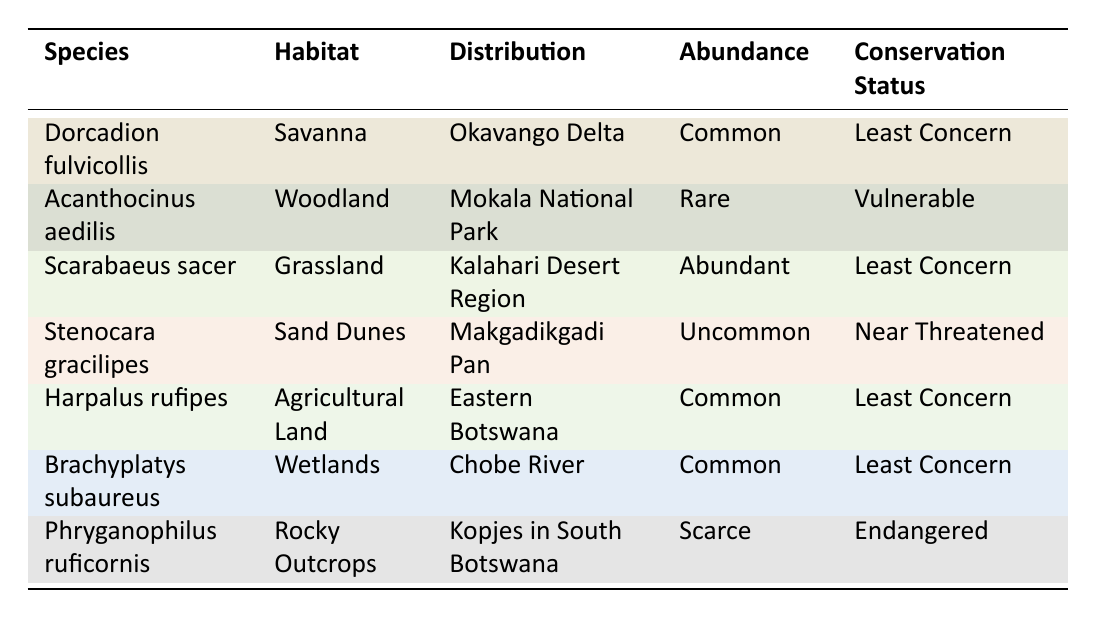What is the conservation status of Dorcadion fulvicollis? The table lists Dorcadion fulvicollis with the corresponding conservation status. Directly referencing the row for this species, it states that its conservation status is "Least Concern."
Answer: Least Concern Which species is found in Mokala National Park? The table lists multiple species along with their distributions. By scanning the distribution column, Acanthocinus aedilis is the species noted to be found in Mokala National Park.
Answer: Acanthocinus aedilis How many species have a conservation status of Endangered? The table indicates the conservation statuses of several beetle species. By reviewing the table, Phryganophilus ruficornis is the only species classified as Endangered, making the total count 1.
Answer: 1 Are there any abundant beetle species located in wetlands? The table specifies the abundance of beetle species alongside their habitats. It identifies Brachyplatys subaureus as being "Common" in wetlands, which implies it is abundant in that habitat.
Answer: Yes Which habitat has the greatest number of species listed? By analyzing the table, we see that each row corresponds to one species in each unique habitat. The habitats listed are Savanna, Woodland, Grassland, Sand Dunes, Agricultural Land, Wetlands, and Rocky Outcrops – which all contain only one species each. Therefore, none has more than one species associated with it.
Answer: None What is the abundance of Stenocara gracilipes and how does it compare to Harpalus rufipes? The table shows that Stenocara gracilipes has an abundance of "Uncommon," while Harpalus rufipes is categorized as "Common." Therefore, Harpalus rufipes is more abundant than Stenocara gracilipes.
Answer: Uncommon; Harpalus rufipes is more abundant Which species is found in the Kalahari Desert Region and what is its conservation status? The table states that Scarabaeus sacer is the species located in the Kalahari Desert Region, with its conservation status designated as "Least Concern."
Answer: Scarabaeus sacer; Least Concern What is the distribution of the species with the lowest conservation status? Among the seven species listed, Phryganophilus ruficornis has the lowest conservation status of "Endangered." According to the table, this species is distributed in "Kopjes in South Botswana."
Answer: Kopjes in South Botswana How many species are classified as Common across different habitats? By examining the table, there are three species classified as "Common": Dorcadion fulvicollis, Harpalus rufipes, and Brachyplatys subaureus. Adding these gives a total of three species.
Answer: 3 